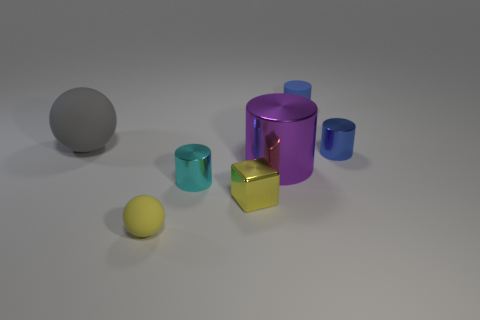There is a sphere that is behind the blue metal cylinder; what is its size?
Your answer should be very brief. Large. How many blocks are the same material as the large purple cylinder?
Provide a succinct answer. 1. The matte object that is the same color as the small metallic cube is what shape?
Offer a very short reply. Sphere. There is a metal object that is right of the large purple metallic cylinder; is it the same shape as the big purple thing?
Make the answer very short. Yes. There is a small block that is made of the same material as the large cylinder; what is its color?
Offer a very short reply. Yellow. There is a large thing on the left side of the ball in front of the large purple cylinder; are there any cylinders in front of it?
Keep it short and to the point. Yes. There is a small blue matte thing; what shape is it?
Make the answer very short. Cylinder. Is the number of cyan metal cylinders in front of the big metal thing less than the number of large purple rubber cylinders?
Provide a short and direct response. No. Are there any tiny blue things of the same shape as the tiny cyan shiny object?
Provide a short and direct response. Yes. The blue metal object that is the same size as the shiny cube is what shape?
Your answer should be very brief. Cylinder. 